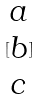Convert formula to latex. <formula><loc_0><loc_0><loc_500><loc_500>[ \begin{matrix} a \\ b \\ c \end{matrix} ]</formula> 